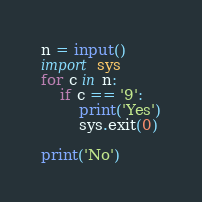Convert code to text. <code><loc_0><loc_0><loc_500><loc_500><_Python_>n = input()
import sys
for c in n:
    if c == '9':
        print('Yes')
        sys.exit(0)

print('No')

</code> 